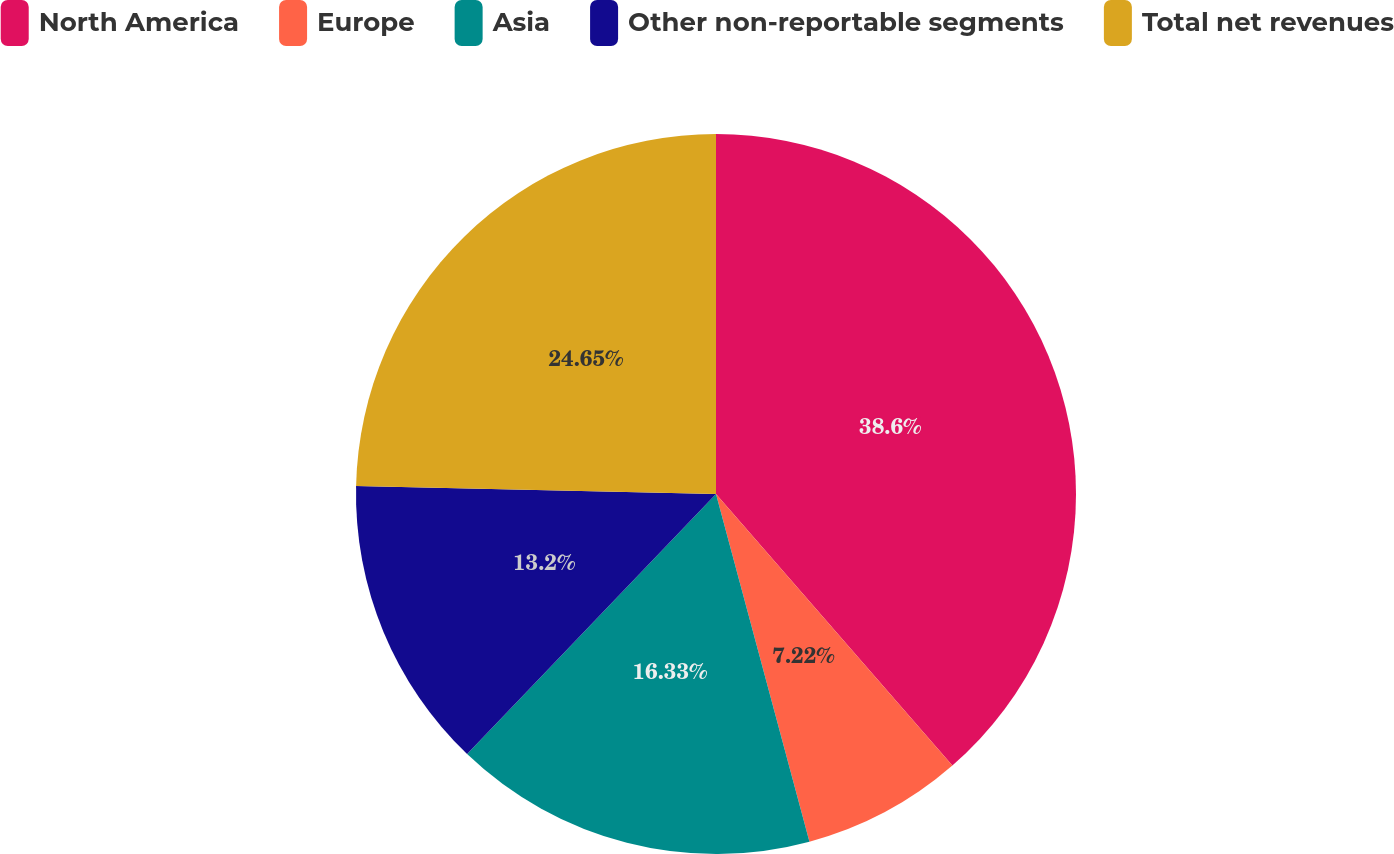Convert chart to OTSL. <chart><loc_0><loc_0><loc_500><loc_500><pie_chart><fcel>North America<fcel>Europe<fcel>Asia<fcel>Other non-reportable segments<fcel>Total net revenues<nl><fcel>38.6%<fcel>7.22%<fcel>16.33%<fcel>13.2%<fcel>24.65%<nl></chart> 